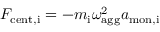Convert formula to latex. <formula><loc_0><loc_0><loc_500><loc_500>F _ { c e n t , i } = - m _ { i } \omega _ { a g g } ^ { 2 } a _ { m o n , i }</formula> 